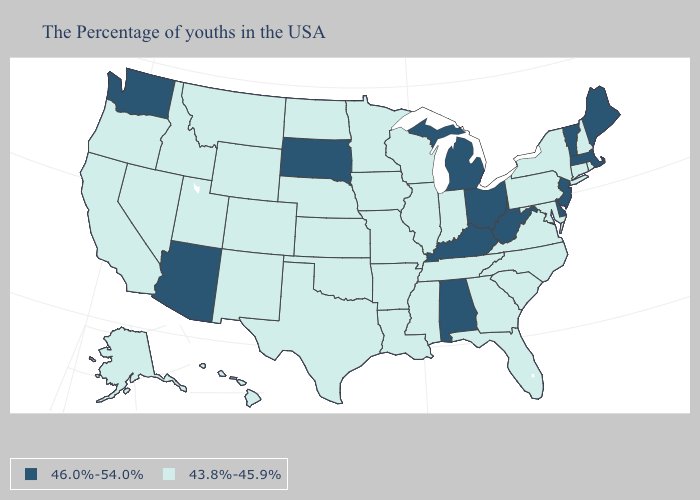Does Michigan have the highest value in the MidWest?
Give a very brief answer. Yes. What is the lowest value in the South?
Give a very brief answer. 43.8%-45.9%. Among the states that border Colorado , does Nebraska have the lowest value?
Give a very brief answer. Yes. Does the map have missing data?
Short answer required. No. What is the lowest value in states that border Florida?
Answer briefly. 43.8%-45.9%. Does New Hampshire have the lowest value in the Northeast?
Give a very brief answer. Yes. Does Pennsylvania have the same value as Florida?
Concise answer only. Yes. What is the value of South Carolina?
Be succinct. 43.8%-45.9%. What is the value of Wisconsin?
Be succinct. 43.8%-45.9%. What is the value of New Hampshire?
Be succinct. 43.8%-45.9%. What is the lowest value in the USA?
Keep it brief. 43.8%-45.9%. Name the states that have a value in the range 43.8%-45.9%?
Keep it brief. Rhode Island, New Hampshire, Connecticut, New York, Maryland, Pennsylvania, Virginia, North Carolina, South Carolina, Florida, Georgia, Indiana, Tennessee, Wisconsin, Illinois, Mississippi, Louisiana, Missouri, Arkansas, Minnesota, Iowa, Kansas, Nebraska, Oklahoma, Texas, North Dakota, Wyoming, Colorado, New Mexico, Utah, Montana, Idaho, Nevada, California, Oregon, Alaska, Hawaii. Name the states that have a value in the range 46.0%-54.0%?
Answer briefly. Maine, Massachusetts, Vermont, New Jersey, Delaware, West Virginia, Ohio, Michigan, Kentucky, Alabama, South Dakota, Arizona, Washington. Name the states that have a value in the range 43.8%-45.9%?
Concise answer only. Rhode Island, New Hampshire, Connecticut, New York, Maryland, Pennsylvania, Virginia, North Carolina, South Carolina, Florida, Georgia, Indiana, Tennessee, Wisconsin, Illinois, Mississippi, Louisiana, Missouri, Arkansas, Minnesota, Iowa, Kansas, Nebraska, Oklahoma, Texas, North Dakota, Wyoming, Colorado, New Mexico, Utah, Montana, Idaho, Nevada, California, Oregon, Alaska, Hawaii. Does the first symbol in the legend represent the smallest category?
Answer briefly. No. 